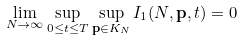<formula> <loc_0><loc_0><loc_500><loc_500>\lim _ { N \to \infty } \sup _ { 0 \leq t \leq T } \sup _ { { \mathbf p } \in K _ { N } } I _ { 1 } ( N , { \mathbf p } , t ) = 0</formula> 